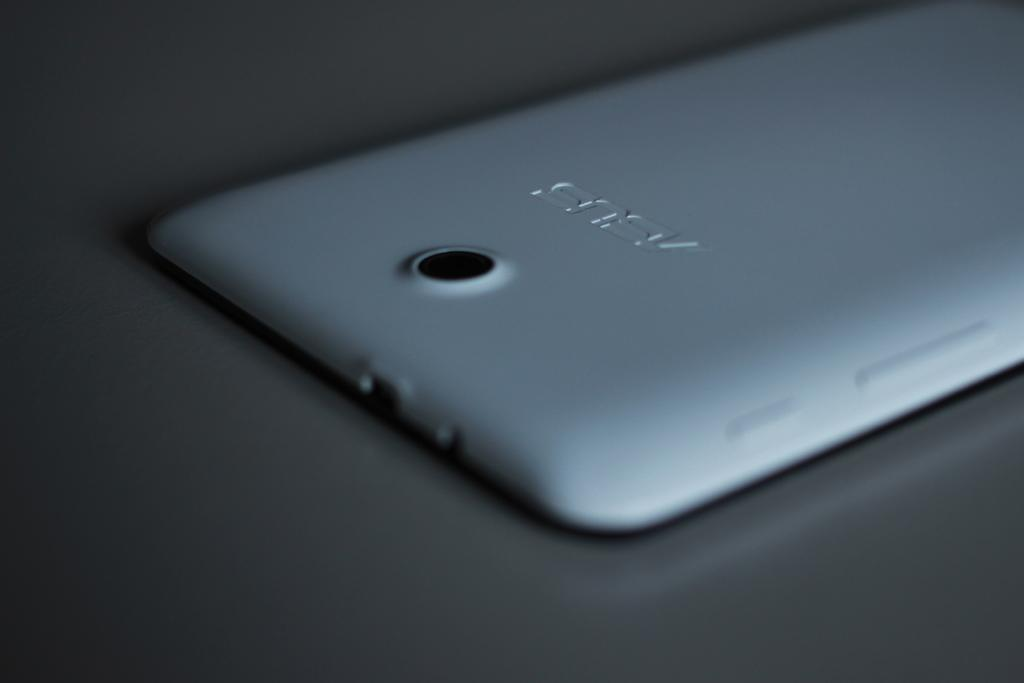<image>
Describe the image concisely. a silver phone that says 'asus' on the back of it 